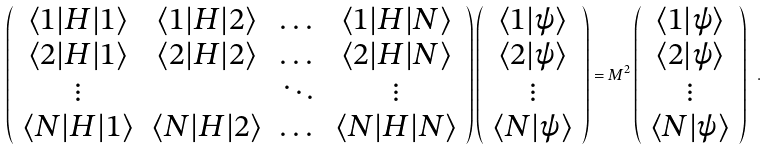<formula> <loc_0><loc_0><loc_500><loc_500>\left ( \begin{array} { c c c c } \langle 1 | H | 1 \rangle & \langle 1 | H | 2 \rangle & \dots & \langle 1 | H | N \rangle \\ \langle 2 | H | 1 \rangle & \langle 2 | H | 2 \rangle & \dots & \langle 2 | H | N \rangle \\ \vdots & & \ddots & \vdots \\ \langle N | H | 1 \rangle & \langle N | H | 2 \rangle & \dots & \langle N | H | N \rangle \end{array} \right ) \left ( \begin{array} { c } \langle 1 | \psi \rangle \\ \langle 2 | \psi \rangle \\ \vdots \\ \langle N | \psi \rangle \end{array} \right ) = M ^ { 2 } \left ( \begin{array} { c } \langle 1 | \psi \rangle \\ \langle 2 | \psi \rangle \\ \vdots \\ \langle N | \psi \rangle \end{array} \right ) \ .</formula> 